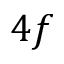<formula> <loc_0><loc_0><loc_500><loc_500>4 f</formula> 